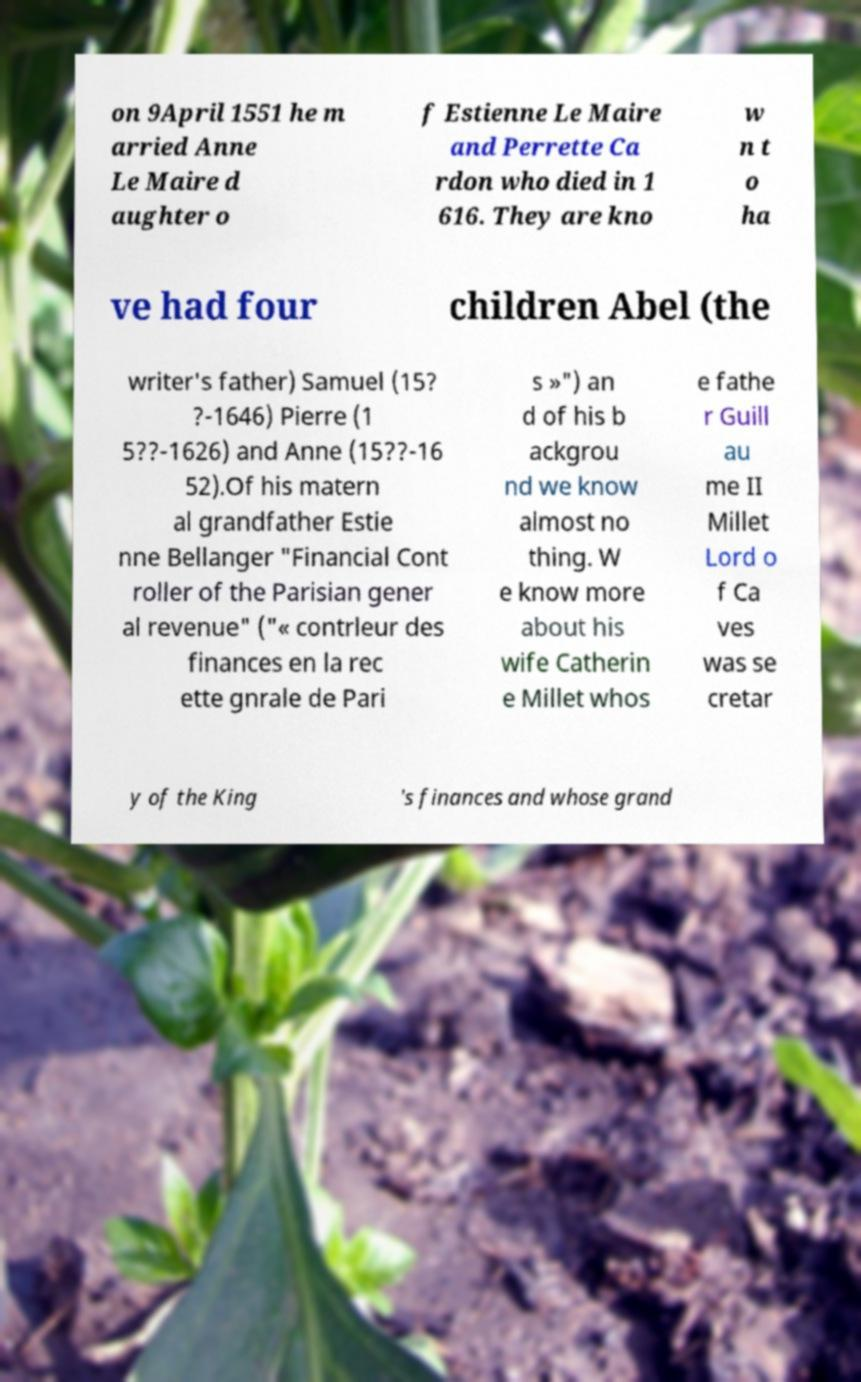Could you assist in decoding the text presented in this image and type it out clearly? on 9April 1551 he m arried Anne Le Maire d aughter o f Estienne Le Maire and Perrette Ca rdon who died in 1 616. They are kno w n t o ha ve had four children Abel (the writer's father) Samuel (15? ?-1646) Pierre (1 5??-1626) and Anne (15??-16 52).Of his matern al grandfather Estie nne Bellanger "Financial Cont roller of the Parisian gener al revenue" ("« contrleur des finances en la rec ette gnrale de Pari s »") an d of his b ackgrou nd we know almost no thing. W e know more about his wife Catherin e Millet whos e fathe r Guill au me II Millet Lord o f Ca ves was se cretar y of the King 's finances and whose grand 